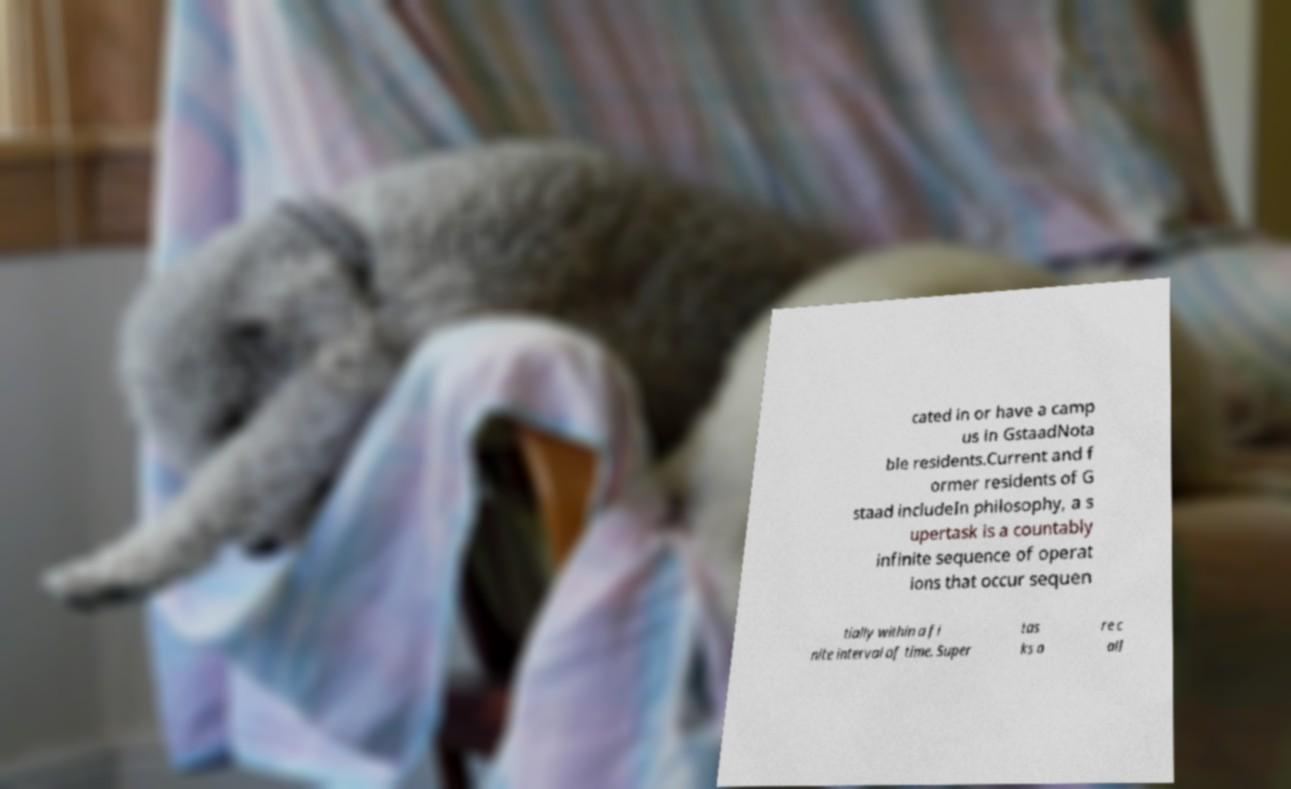Please read and relay the text visible in this image. What does it say? cated in or have a camp us in GstaadNota ble residents.Current and f ormer residents of G staad includeIn philosophy, a s upertask is a countably infinite sequence of operat ions that occur sequen tially within a fi nite interval of time. Super tas ks a re c all 